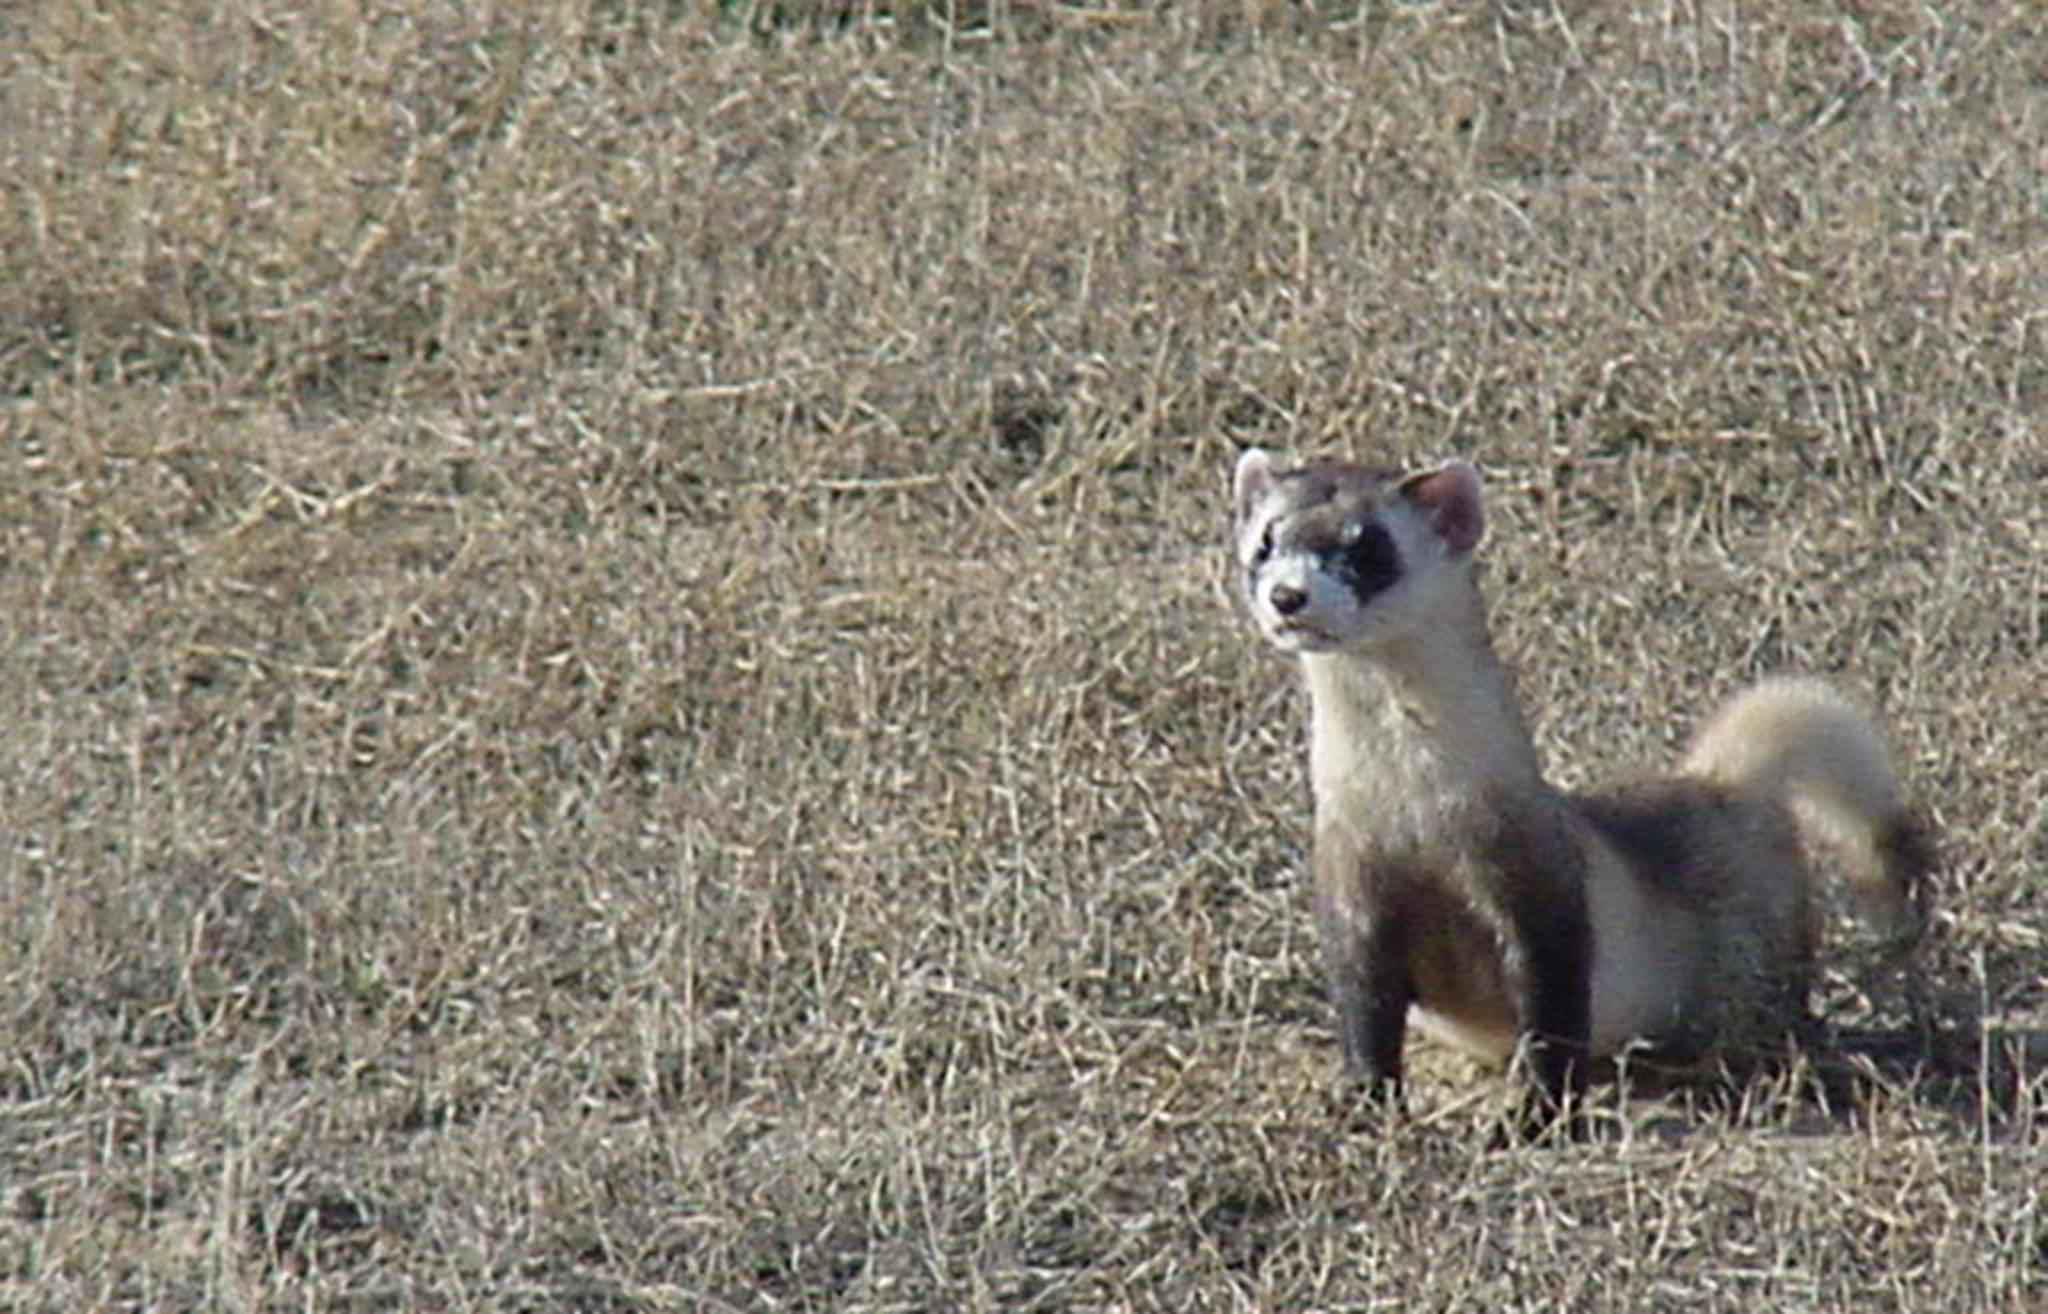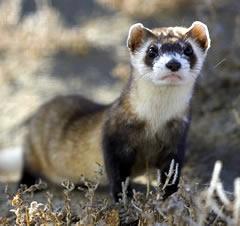The first image is the image on the left, the second image is the image on the right. Assess this claim about the two images: "One of the animal's tail is curved". Correct or not? Answer yes or no. Yes. 